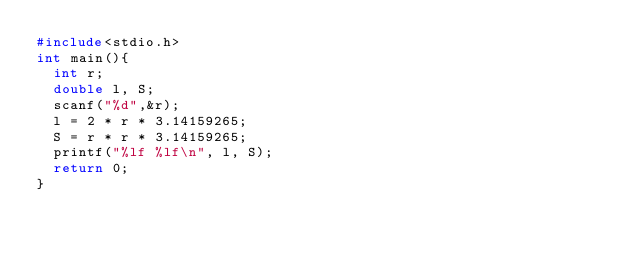<code> <loc_0><loc_0><loc_500><loc_500><_C_>#include<stdio.h>
int main(){
  int r;
  double l, S;
  scanf("%d",&r);
  l = 2 * r * 3.14159265;
  S = r * r * 3.14159265;
  printf("%lf %lf\n", l, S);
  return 0;
}
</code> 